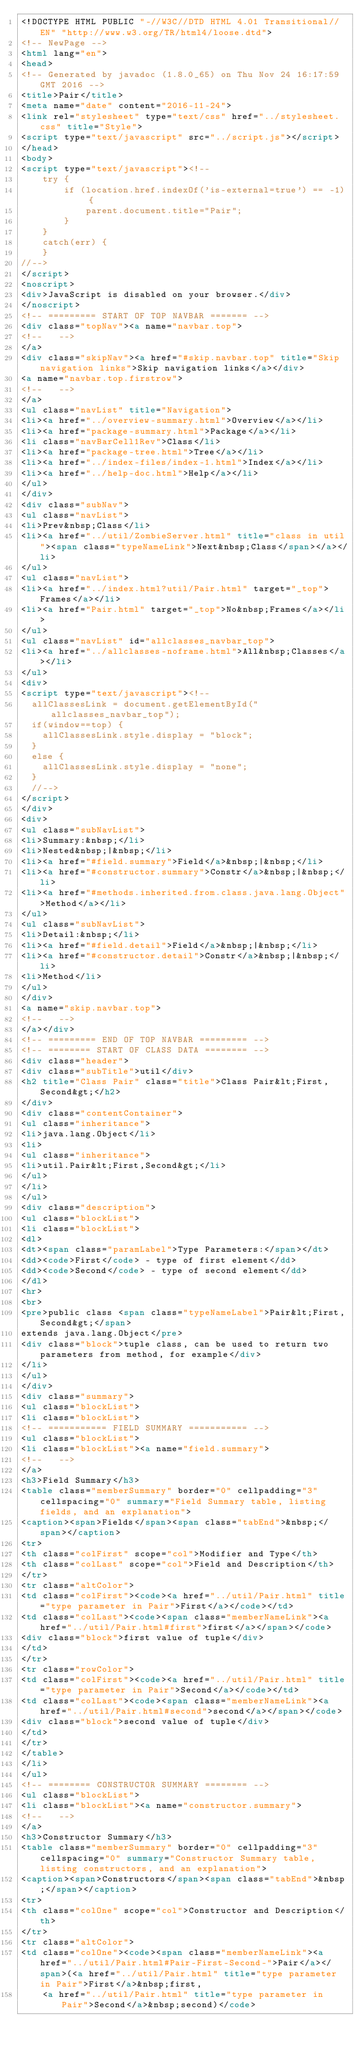Convert code to text. <code><loc_0><loc_0><loc_500><loc_500><_HTML_><!DOCTYPE HTML PUBLIC "-//W3C//DTD HTML 4.01 Transitional//EN" "http://www.w3.org/TR/html4/loose.dtd">
<!-- NewPage -->
<html lang="en">
<head>
<!-- Generated by javadoc (1.8.0_65) on Thu Nov 24 16:17:59 GMT 2016 -->
<title>Pair</title>
<meta name="date" content="2016-11-24">
<link rel="stylesheet" type="text/css" href="../stylesheet.css" title="Style">
<script type="text/javascript" src="../script.js"></script>
</head>
<body>
<script type="text/javascript"><!--
    try {
        if (location.href.indexOf('is-external=true') == -1) {
            parent.document.title="Pair";
        }
    }
    catch(err) {
    }
//-->
</script>
<noscript>
<div>JavaScript is disabled on your browser.</div>
</noscript>
<!-- ========= START OF TOP NAVBAR ======= -->
<div class="topNav"><a name="navbar.top">
<!--   -->
</a>
<div class="skipNav"><a href="#skip.navbar.top" title="Skip navigation links">Skip navigation links</a></div>
<a name="navbar.top.firstrow">
<!--   -->
</a>
<ul class="navList" title="Navigation">
<li><a href="../overview-summary.html">Overview</a></li>
<li><a href="package-summary.html">Package</a></li>
<li class="navBarCell1Rev">Class</li>
<li><a href="package-tree.html">Tree</a></li>
<li><a href="../index-files/index-1.html">Index</a></li>
<li><a href="../help-doc.html">Help</a></li>
</ul>
</div>
<div class="subNav">
<ul class="navList">
<li>Prev&nbsp;Class</li>
<li><a href="../util/ZombieServer.html" title="class in util"><span class="typeNameLink">Next&nbsp;Class</span></a></li>
</ul>
<ul class="navList">
<li><a href="../index.html?util/Pair.html" target="_top">Frames</a></li>
<li><a href="Pair.html" target="_top">No&nbsp;Frames</a></li>
</ul>
<ul class="navList" id="allclasses_navbar_top">
<li><a href="../allclasses-noframe.html">All&nbsp;Classes</a></li>
</ul>
<div>
<script type="text/javascript"><!--
  allClassesLink = document.getElementById("allclasses_navbar_top");
  if(window==top) {
    allClassesLink.style.display = "block";
  }
  else {
    allClassesLink.style.display = "none";
  }
  //-->
</script>
</div>
<div>
<ul class="subNavList">
<li>Summary:&nbsp;</li>
<li>Nested&nbsp;|&nbsp;</li>
<li><a href="#field.summary">Field</a>&nbsp;|&nbsp;</li>
<li><a href="#constructor.summary">Constr</a>&nbsp;|&nbsp;</li>
<li><a href="#methods.inherited.from.class.java.lang.Object">Method</a></li>
</ul>
<ul class="subNavList">
<li>Detail:&nbsp;</li>
<li><a href="#field.detail">Field</a>&nbsp;|&nbsp;</li>
<li><a href="#constructor.detail">Constr</a>&nbsp;|&nbsp;</li>
<li>Method</li>
</ul>
</div>
<a name="skip.navbar.top">
<!--   -->
</a></div>
<!-- ========= END OF TOP NAVBAR ========= -->
<!-- ======== START OF CLASS DATA ======== -->
<div class="header">
<div class="subTitle">util</div>
<h2 title="Class Pair" class="title">Class Pair&lt;First,Second&gt;</h2>
</div>
<div class="contentContainer">
<ul class="inheritance">
<li>java.lang.Object</li>
<li>
<ul class="inheritance">
<li>util.Pair&lt;First,Second&gt;</li>
</ul>
</li>
</ul>
<div class="description">
<ul class="blockList">
<li class="blockList">
<dl>
<dt><span class="paramLabel">Type Parameters:</span></dt>
<dd><code>First</code> - type of first element</dd>
<dd><code>Second</code> - type of second element</dd>
</dl>
<hr>
<br>
<pre>public class <span class="typeNameLabel">Pair&lt;First,Second&gt;</span>
extends java.lang.Object</pre>
<div class="block">tuple class, can be used to return two parameters from method, for example</div>
</li>
</ul>
</div>
<div class="summary">
<ul class="blockList">
<li class="blockList">
<!-- =========== FIELD SUMMARY =========== -->
<ul class="blockList">
<li class="blockList"><a name="field.summary">
<!--   -->
</a>
<h3>Field Summary</h3>
<table class="memberSummary" border="0" cellpadding="3" cellspacing="0" summary="Field Summary table, listing fields, and an explanation">
<caption><span>Fields</span><span class="tabEnd">&nbsp;</span></caption>
<tr>
<th class="colFirst" scope="col">Modifier and Type</th>
<th class="colLast" scope="col">Field and Description</th>
</tr>
<tr class="altColor">
<td class="colFirst"><code><a href="../util/Pair.html" title="type parameter in Pair">First</a></code></td>
<td class="colLast"><code><span class="memberNameLink"><a href="../util/Pair.html#first">first</a></span></code>
<div class="block">first value of tuple</div>
</td>
</tr>
<tr class="rowColor">
<td class="colFirst"><code><a href="../util/Pair.html" title="type parameter in Pair">Second</a></code></td>
<td class="colLast"><code><span class="memberNameLink"><a href="../util/Pair.html#second">second</a></span></code>
<div class="block">second value of tuple</div>
</td>
</tr>
</table>
</li>
</ul>
<!-- ======== CONSTRUCTOR SUMMARY ======== -->
<ul class="blockList">
<li class="blockList"><a name="constructor.summary">
<!--   -->
</a>
<h3>Constructor Summary</h3>
<table class="memberSummary" border="0" cellpadding="3" cellspacing="0" summary="Constructor Summary table, listing constructors, and an explanation">
<caption><span>Constructors</span><span class="tabEnd">&nbsp;</span></caption>
<tr>
<th class="colOne" scope="col">Constructor and Description</th>
</tr>
<tr class="altColor">
<td class="colOne"><code><span class="memberNameLink"><a href="../util/Pair.html#Pair-First-Second-">Pair</a></span>(<a href="../util/Pair.html" title="type parameter in Pair">First</a>&nbsp;first,
    <a href="../util/Pair.html" title="type parameter in Pair">Second</a>&nbsp;second)</code></code> 